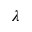<formula> <loc_0><loc_0><loc_500><loc_500>\lambda</formula> 